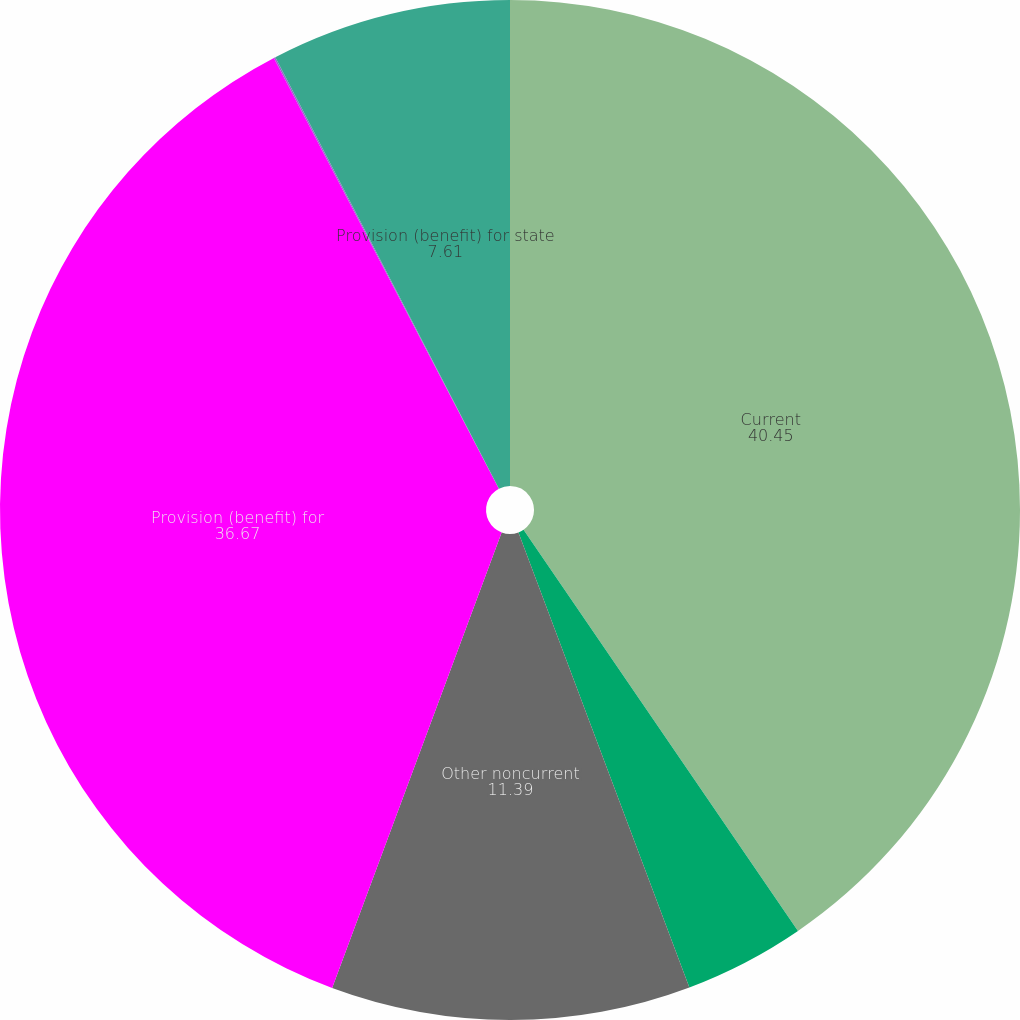Convert chart to OTSL. <chart><loc_0><loc_0><loc_500><loc_500><pie_chart><fcel>Current<fcel>Deferred (excluding operating<fcel>Other noncurrent<fcel>Provision (benefit) for<fcel>Deferred-operating loss<fcel>Provision (benefit) for state<nl><fcel>40.45%<fcel>3.83%<fcel>11.39%<fcel>36.67%<fcel>0.05%<fcel>7.61%<nl></chart> 